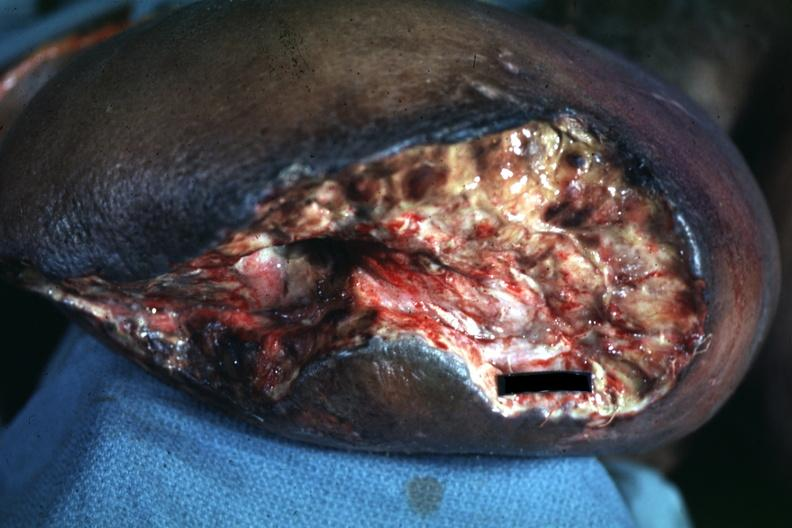re nodules present?
Answer the question using a single word or phrase. No 